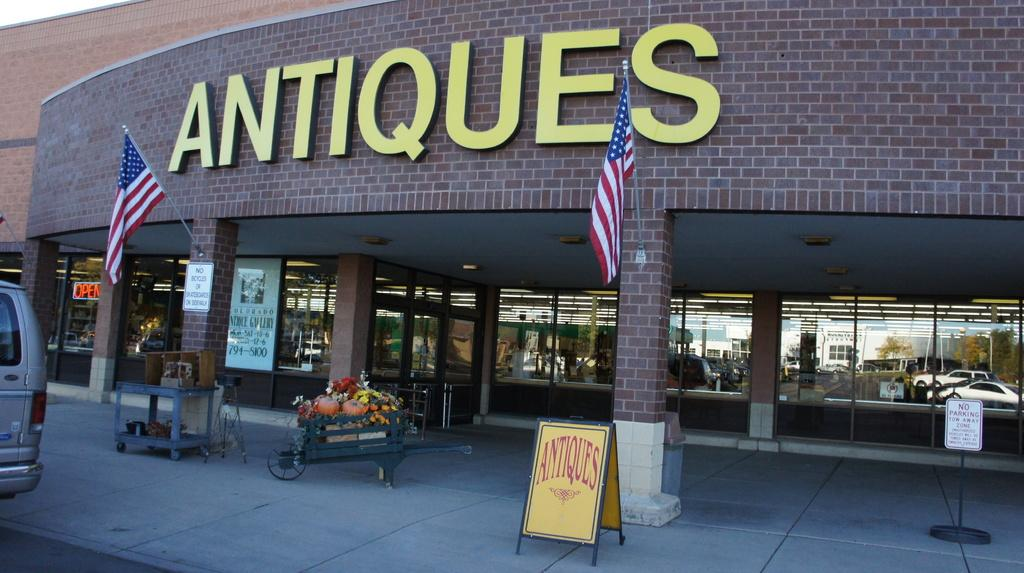What type of structure is visible in the image? There is a building in the image. What architectural features can be seen on the building? There are pillars in the image. What other objects are present in the image? There are boards, a cart, pumpkins, flowers, and glasses in the image. What do the glasses reflect in the image? The glasses reflect buildings, trees, poles, vehicles, and the sky. Where can the glove be found in the image? There is no glove present in the image. What type of soda is being served in the glasses in the image? There is no soda visible in the image; only glasses reflecting various elements are present. 